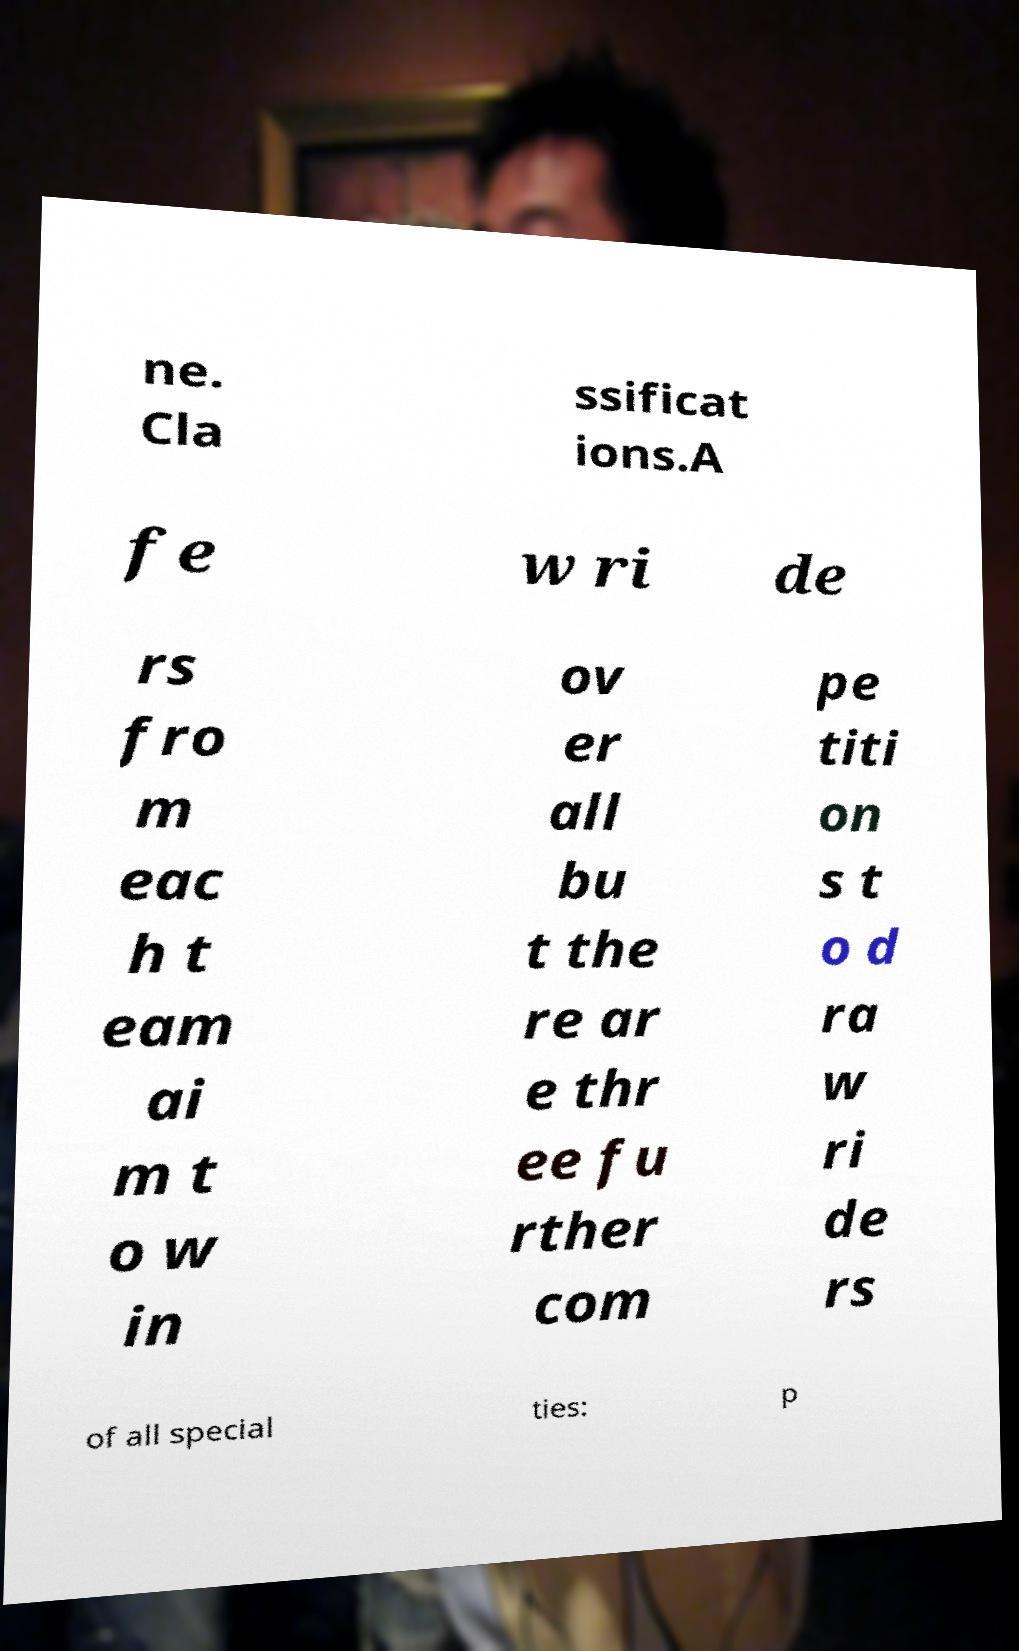Please identify and transcribe the text found in this image. ne. Cla ssificat ions.A fe w ri de rs fro m eac h t eam ai m t o w in ov er all bu t the re ar e thr ee fu rther com pe titi on s t o d ra w ri de rs of all special ties: p 